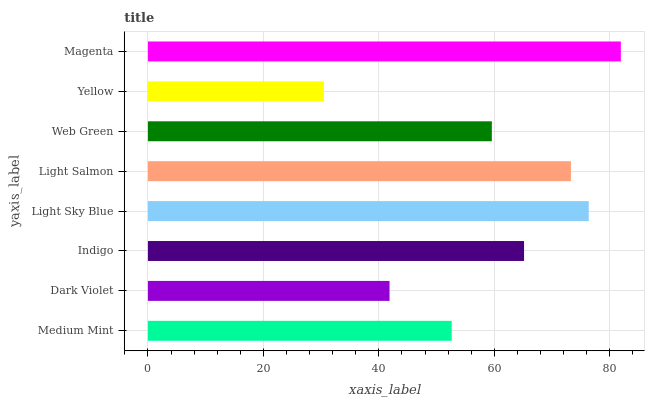Is Yellow the minimum?
Answer yes or no. Yes. Is Magenta the maximum?
Answer yes or no. Yes. Is Dark Violet the minimum?
Answer yes or no. No. Is Dark Violet the maximum?
Answer yes or no. No. Is Medium Mint greater than Dark Violet?
Answer yes or no. Yes. Is Dark Violet less than Medium Mint?
Answer yes or no. Yes. Is Dark Violet greater than Medium Mint?
Answer yes or no. No. Is Medium Mint less than Dark Violet?
Answer yes or no. No. Is Indigo the high median?
Answer yes or no. Yes. Is Web Green the low median?
Answer yes or no. Yes. Is Magenta the high median?
Answer yes or no. No. Is Light Salmon the low median?
Answer yes or no. No. 